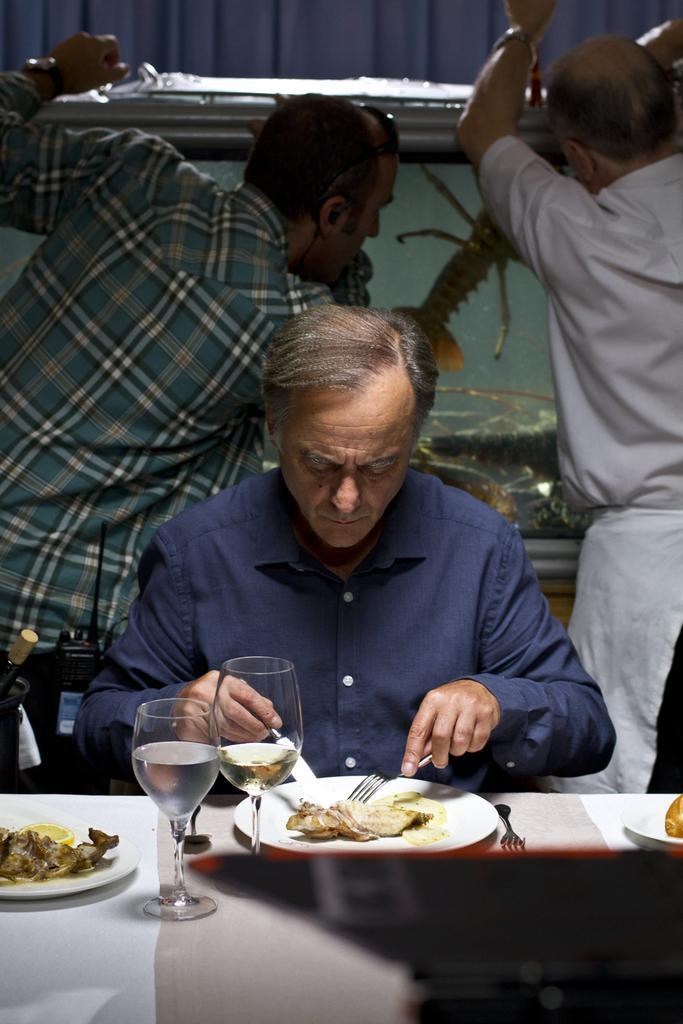Please provide a concise description of this image. In the foreground of the picture there is a table, on the table there are plates, glasses and food items. In the center of the picture there is a man sitting, holding knife and fork. Behind him there are two men standing. In the background there is a curtain and a glass object. 